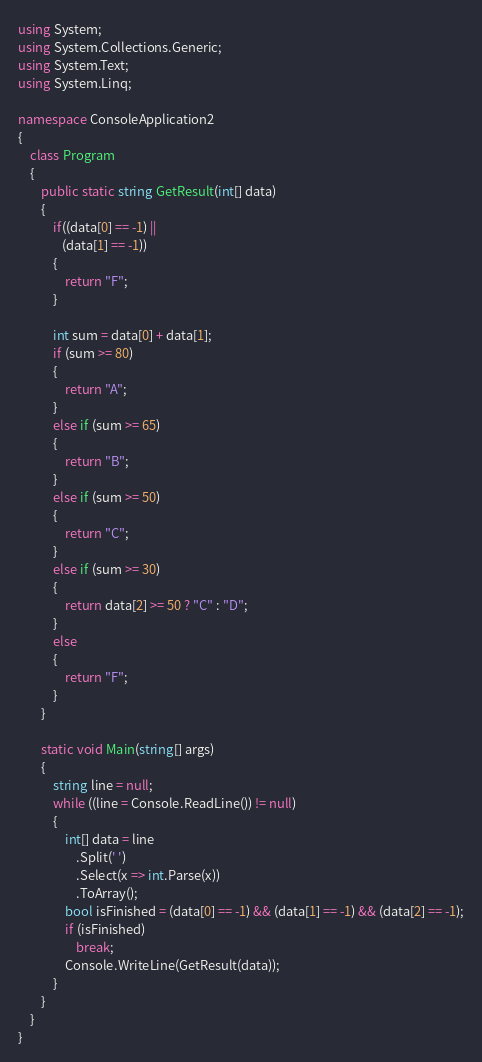<code> <loc_0><loc_0><loc_500><loc_500><_C#_>using System;
using System.Collections.Generic;
using System.Text;
using System.Linq;

namespace ConsoleApplication2
{
    class Program
    {
        public static string GetResult(int[] data)
        {
            if((data[0] == -1) ||
               (data[1] == -1))
            {
                return "F";
            }

            int sum = data[0] + data[1];
            if (sum >= 80)
            {
                return "A";
            }
            else if (sum >= 65)
            {
                return "B";
            }
            else if (sum >= 50)
            {
                return "C";
            }
            else if (sum >= 30)
            {
                return data[2] >= 50 ? "C" : "D";
            }
            else 
            {
                return "F";
            }
        }

        static void Main(string[] args)
        {
            string line = null;
            while ((line = Console.ReadLine()) != null)
            {
                int[] data = line
                    .Split(' ')
                    .Select(x => int.Parse(x))
                    .ToArray();
                bool isFinished = (data[0] == -1) && (data[1] == -1) && (data[2] == -1);
                if (isFinished)
                    break;
                Console.WriteLine(GetResult(data));
            }
        }
    }
}</code> 